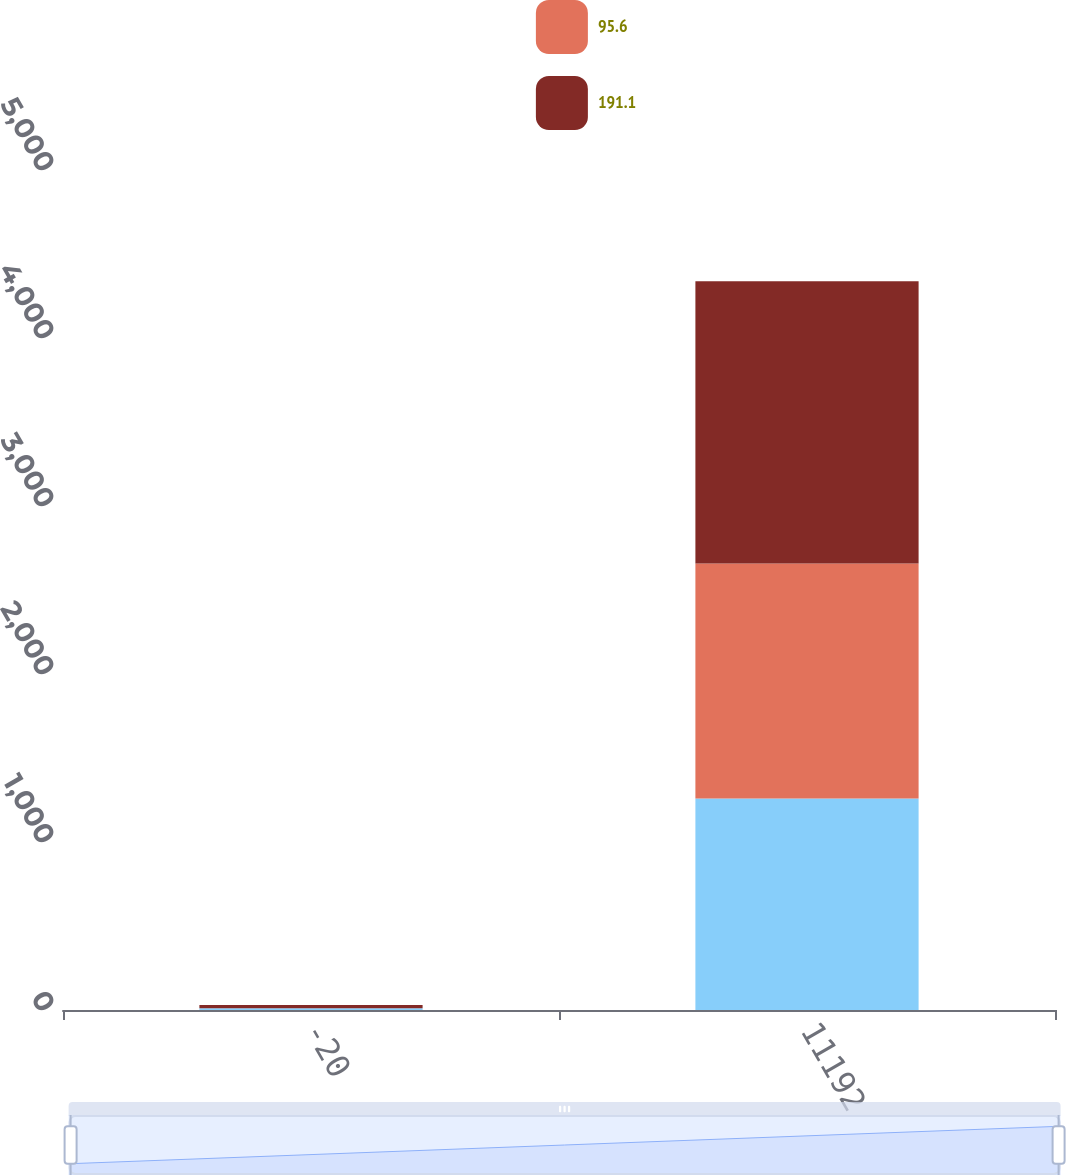Convert chart to OTSL. <chart><loc_0><loc_0><loc_500><loc_500><stacked_bar_chart><ecel><fcel>-20<fcel>11192<nl><fcel>nan<fcel>10<fcel>1259.1<nl><fcel>95.6<fcel>0<fcel>1399.1<nl><fcel>191.1<fcel>20<fcel>1678.9<nl></chart> 